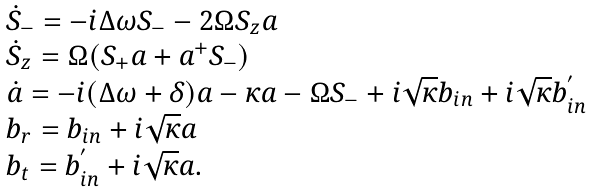<formula> <loc_0><loc_0><loc_500><loc_500>\begin{array} { l } \dot { S } _ { - } = - i \Delta \omega S _ { - } - 2 \Omega S _ { z } a \\ \dot { S } _ { z } = \Omega ( S _ { + } a + a ^ { + } S _ { - } ) \\ \dot { a } = - i ( \Delta \omega + \delta ) a - \kappa a - \Omega S _ { - } + i \sqrt { \kappa } b _ { i n } + i \sqrt { \kappa } b _ { i n } ^ { ^ { \prime } } \\ b _ { r } = b _ { i n } + i \sqrt { \kappa } a \\ b _ { t } = b _ { i n } ^ { ^ { \prime } } + i \sqrt { \kappa } a . \end{array}</formula> 